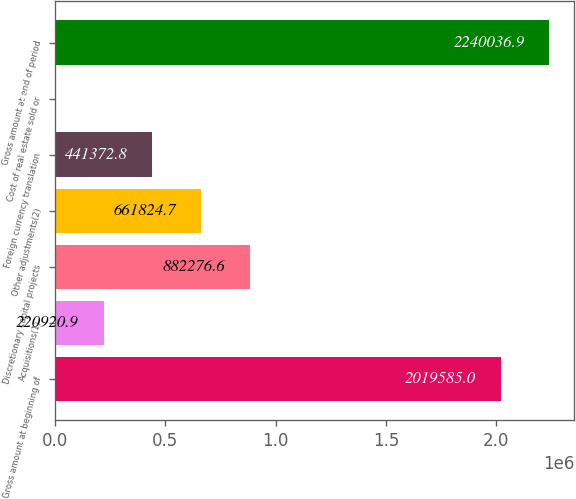Convert chart to OTSL. <chart><loc_0><loc_0><loc_500><loc_500><bar_chart><fcel>Gross amount at beginning of<fcel>Acquisitions(1)<fcel>Discretionary capital projects<fcel>Other adjustments(2)<fcel>Foreign currency translation<fcel>Cost of real estate sold or<fcel>Gross amount at end of period<nl><fcel>2.01958e+06<fcel>220921<fcel>882277<fcel>661825<fcel>441373<fcel>469<fcel>2.24004e+06<nl></chart> 